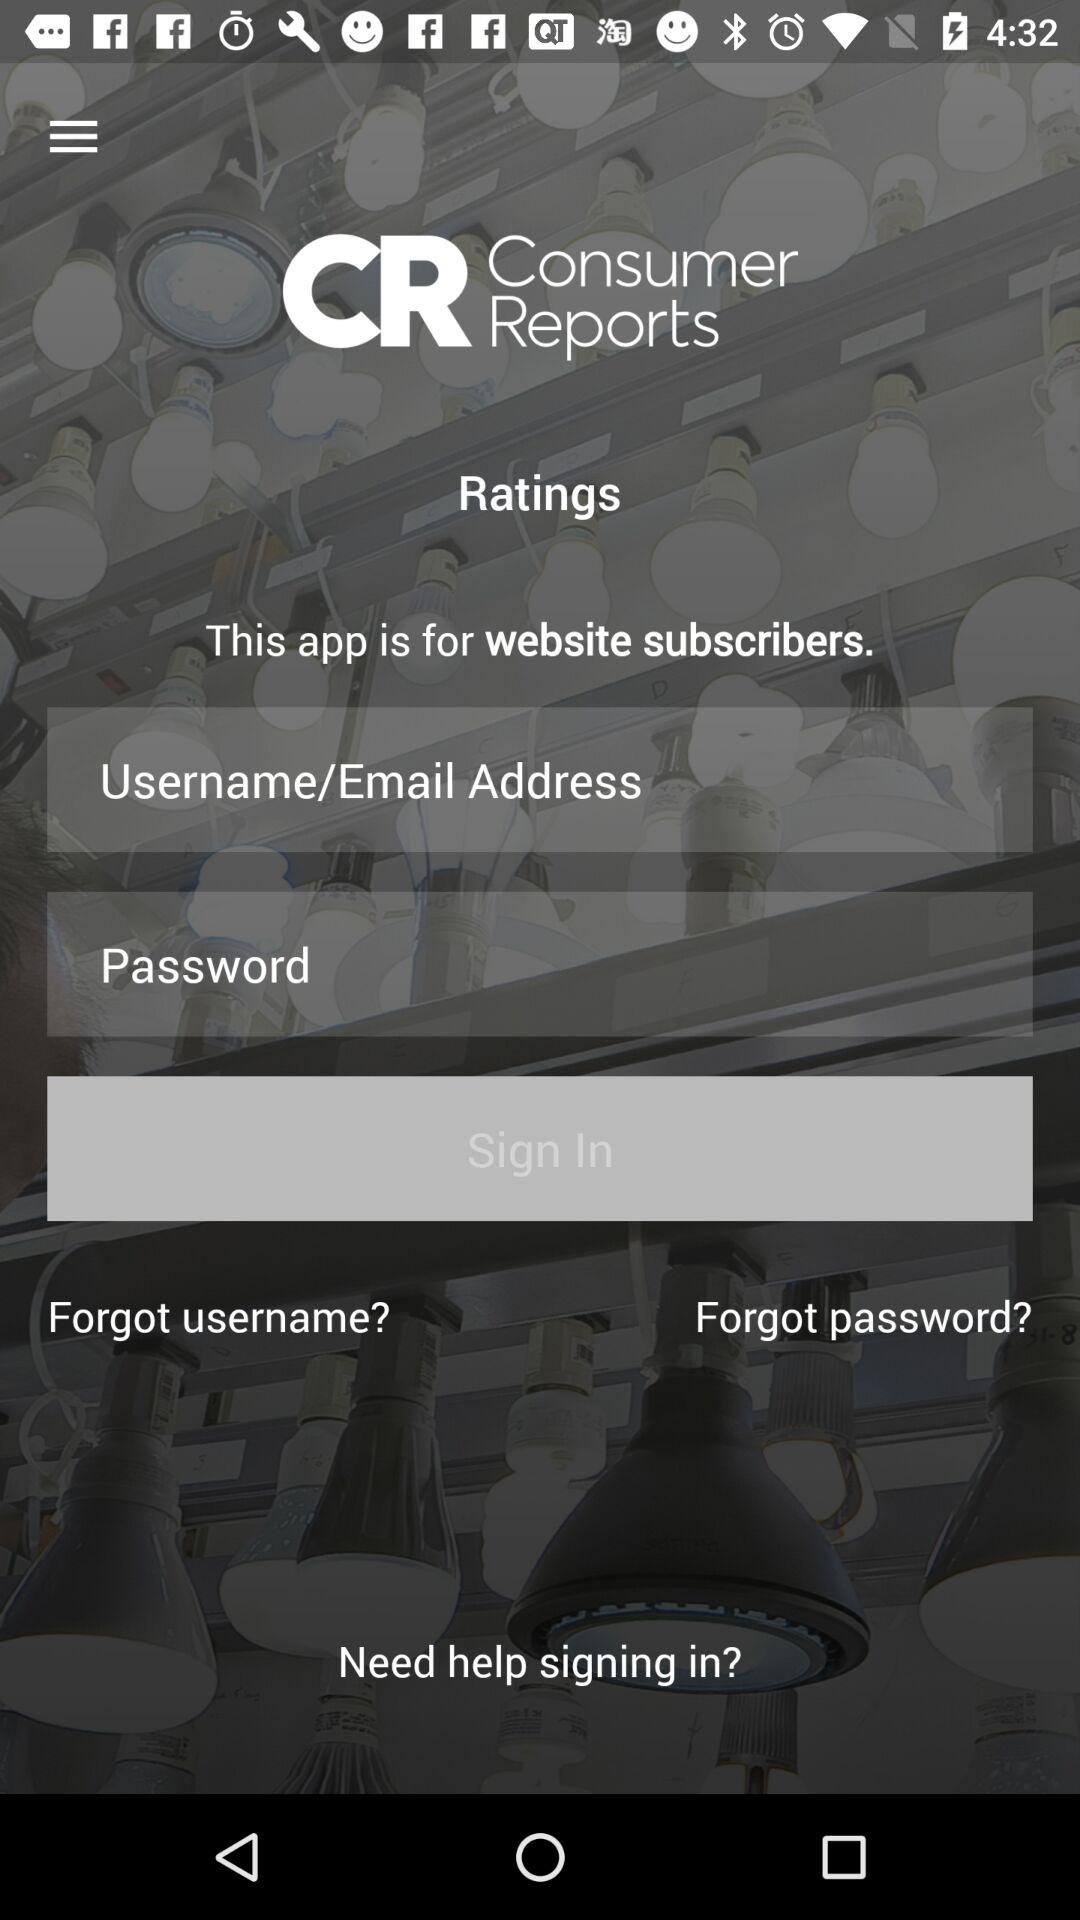Are there any visible options for additional help with signing in? Yes, there is a 'Need help signing in?' link which likely offers further assistance for users experiencing issues with accessing their accounts. 